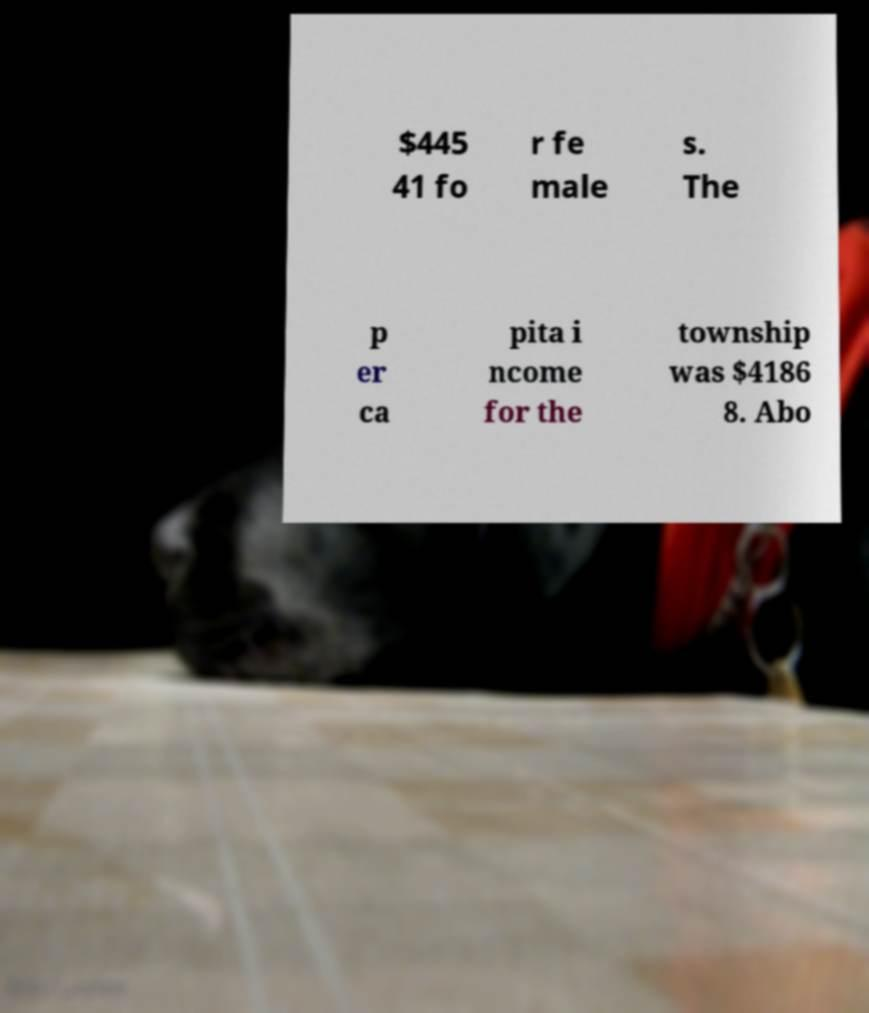Could you extract and type out the text from this image? $445 41 fo r fe male s. The p er ca pita i ncome for the township was $4186 8. Abo 